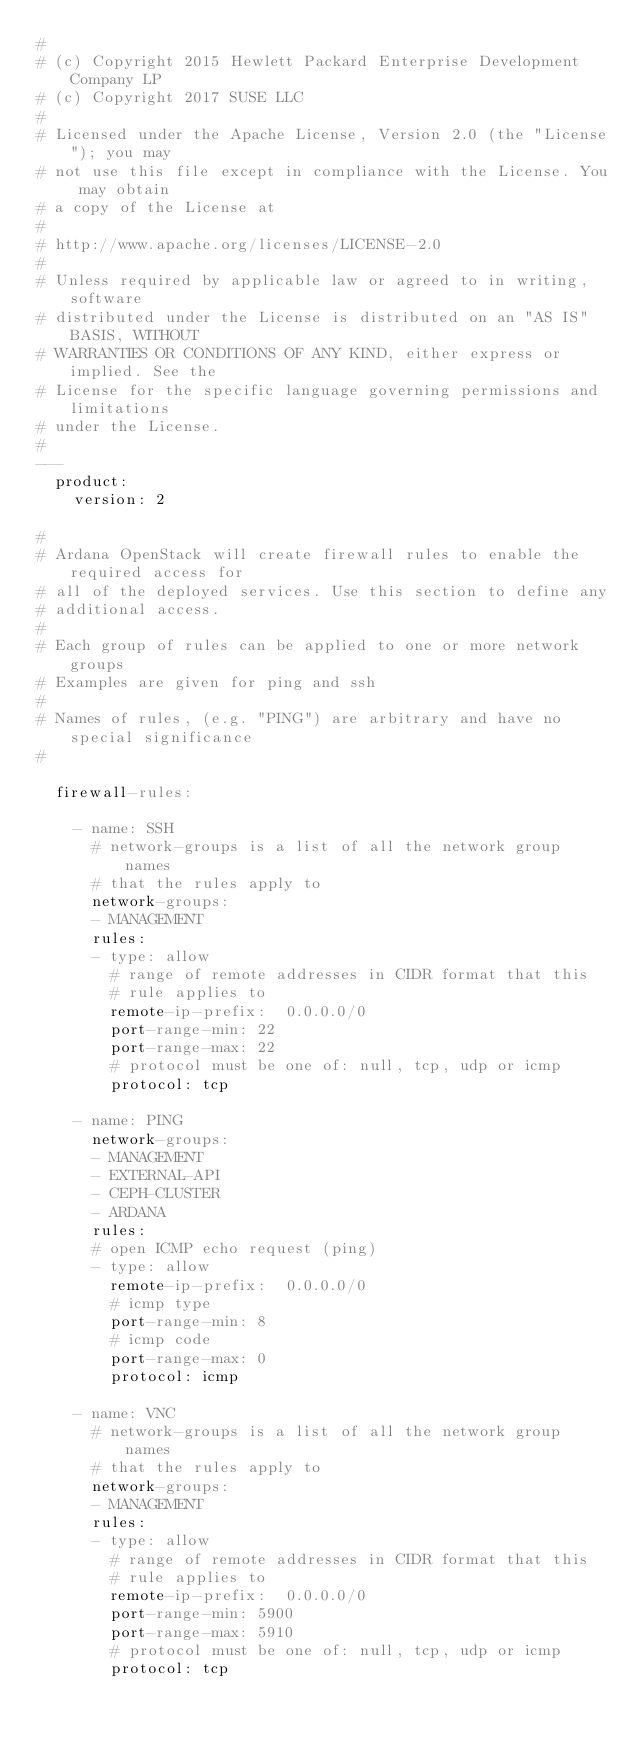<code> <loc_0><loc_0><loc_500><loc_500><_YAML_>#
# (c) Copyright 2015 Hewlett Packard Enterprise Development Company LP
# (c) Copyright 2017 SUSE LLC
#
# Licensed under the Apache License, Version 2.0 (the "License"); you may
# not use this file except in compliance with the License. You may obtain
# a copy of the License at
#
# http://www.apache.org/licenses/LICENSE-2.0
#
# Unless required by applicable law or agreed to in writing, software
# distributed under the License is distributed on an "AS IS" BASIS, WITHOUT
# WARRANTIES OR CONDITIONS OF ANY KIND, either express or implied. See the
# License for the specific language governing permissions and limitations
# under the License.
#
---
  product:
    version: 2

#
# Ardana OpenStack will create firewall rules to enable the required access for
# all of the deployed services. Use this section to define any
# additional access.
#
# Each group of rules can be applied to one or more network groups
# Examples are given for ping and ssh
#
# Names of rules, (e.g. "PING") are arbitrary and have no special significance
#

  firewall-rules:

    - name: SSH
      # network-groups is a list of all the network group names
      # that the rules apply to
      network-groups:
      - MANAGEMENT
      rules:
      - type: allow
        # range of remote addresses in CIDR format that this
        # rule applies to
        remote-ip-prefix:  0.0.0.0/0
        port-range-min: 22
        port-range-max: 22
        # protocol must be one of: null, tcp, udp or icmp
        protocol: tcp

    - name: PING
      network-groups:
      - MANAGEMENT
      - EXTERNAL-API
      - CEPH-CLUSTER
      - ARDANA
      rules:
      # open ICMP echo request (ping)
      - type: allow
        remote-ip-prefix:  0.0.0.0/0
        # icmp type
        port-range-min: 8
        # icmp code
        port-range-max: 0
        protocol: icmp

    - name: VNC
      # network-groups is a list of all the network group names
      # that the rules apply to
      network-groups:
      - MANAGEMENT
      rules:
      - type: allow
        # range of remote addresses in CIDR format that this
        # rule applies to
        remote-ip-prefix:  0.0.0.0/0
        port-range-min: 5900
        port-range-max: 5910
        # protocol must be one of: null, tcp, udp or icmp
        protocol: tcp
</code> 